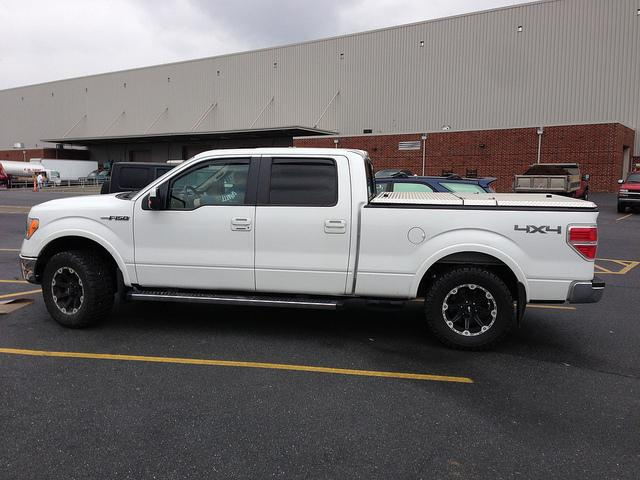What would the answer to the equation on the truck be if the x is replaced by a sign? eight 